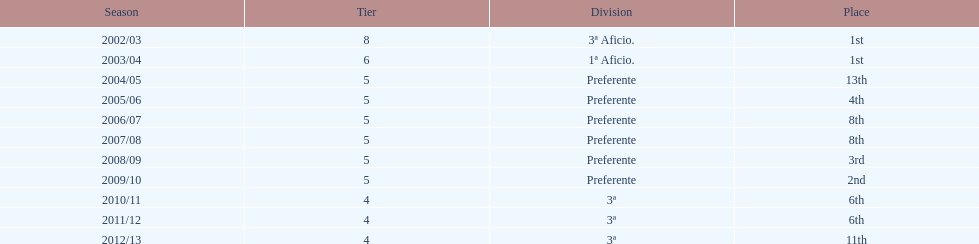How many seasons did internacional de madrid cf play in the preferente division? 6. 